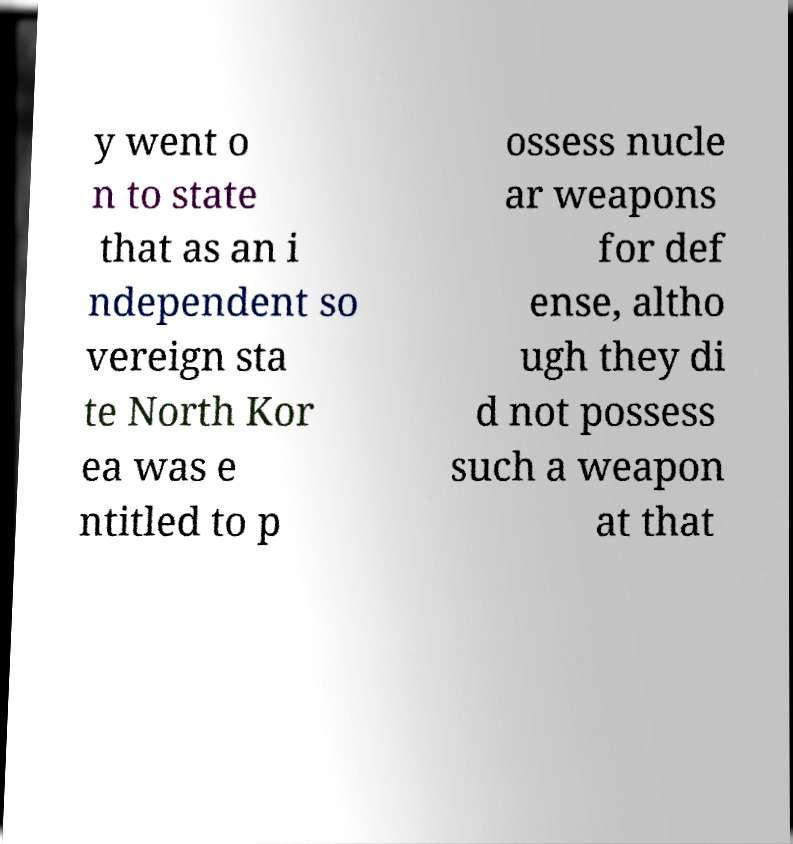I need the written content from this picture converted into text. Can you do that? y went o n to state that as an i ndependent so vereign sta te North Kor ea was e ntitled to p ossess nucle ar weapons for def ense, altho ugh they di d not possess such a weapon at that 